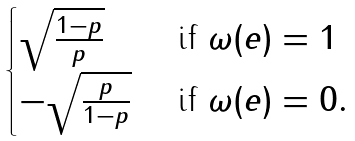<formula> <loc_0><loc_0><loc_500><loc_500>\begin{cases} \sqrt { \frac { 1 - p } { p } } & \text { if } \omega ( e ) = 1 \\ - \sqrt { \frac { p } { 1 - p } } & \text { if } \omega ( e ) = 0 . \end{cases}</formula> 